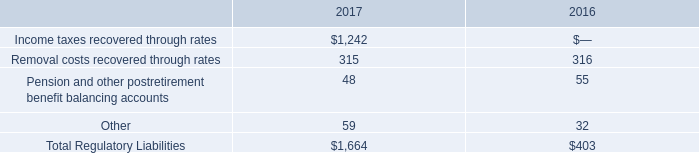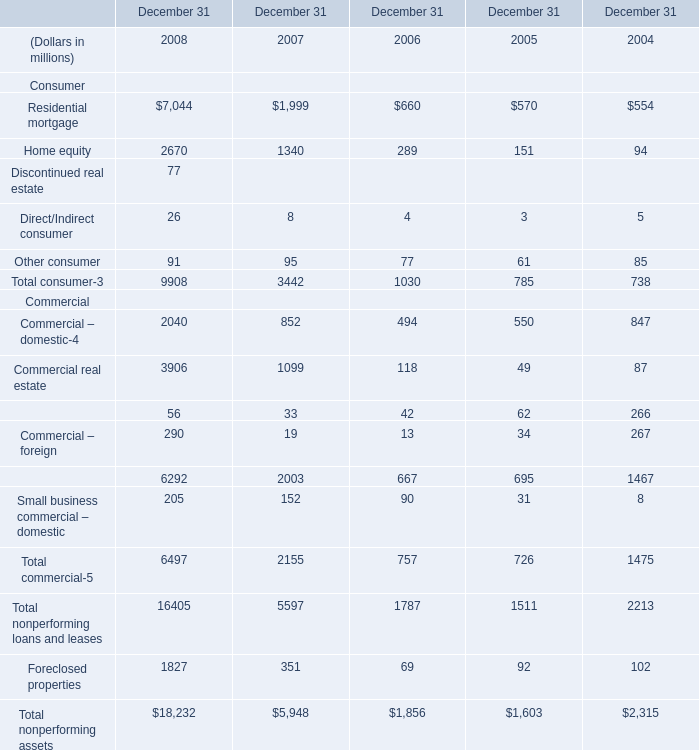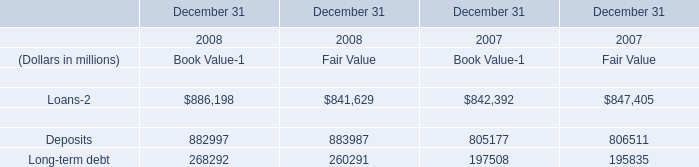What's the difference of direct/indirect consumer between 2007 and 2008? (in million) 
Computations: (26 - 8)
Answer: 18.0. What's the total amount of the commercial in the years where commercial real estate is greater than 2000? (in million) 
Computations: ((((2040 + 3906) + 56) + 290) + 205)
Answer: 6497.0. 